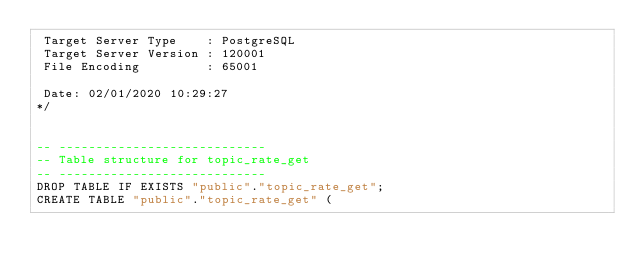<code> <loc_0><loc_0><loc_500><loc_500><_SQL_> Target Server Type    : PostgreSQL
 Target Server Version : 120001
 File Encoding         : 65001

 Date: 02/01/2020 10:29:27
*/


-- ----------------------------
-- Table structure for topic_rate_get
-- ----------------------------
DROP TABLE IF EXISTS "public"."topic_rate_get";
CREATE TABLE "public"."topic_rate_get" (</code> 